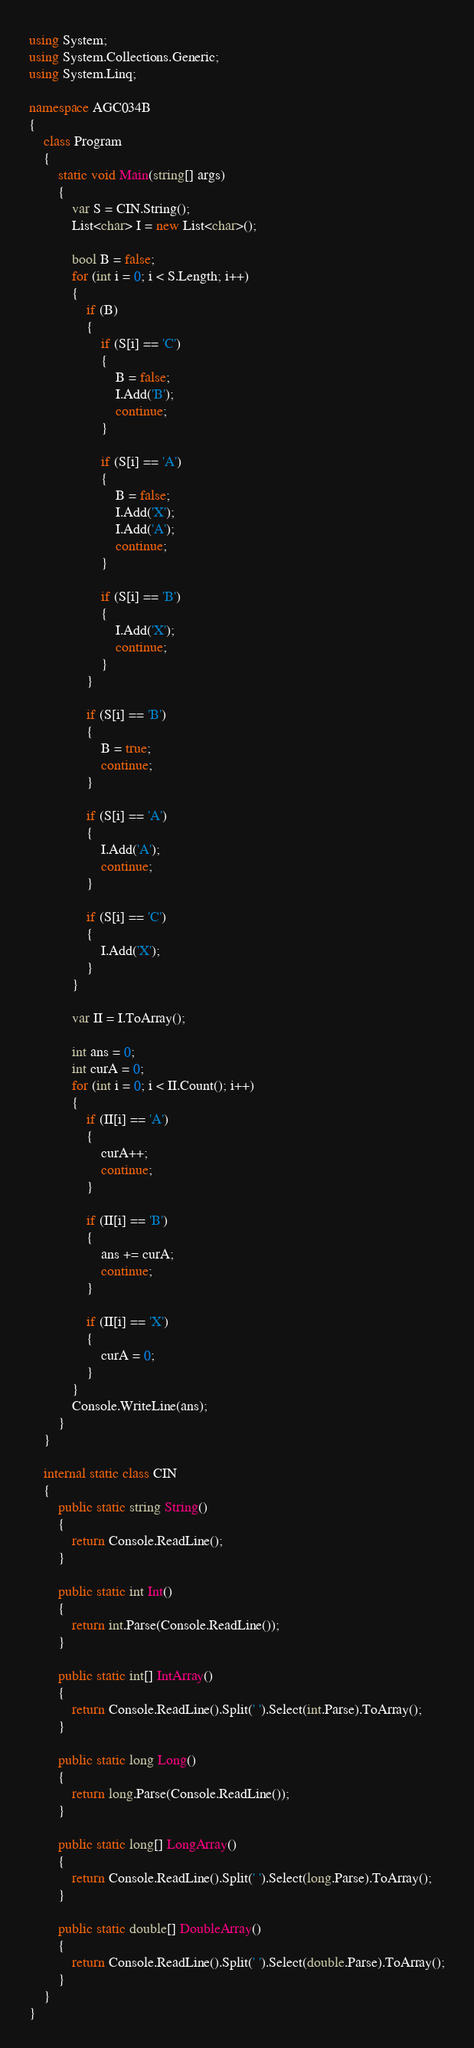<code> <loc_0><loc_0><loc_500><loc_500><_C#_>using System;
using System.Collections.Generic;
using System.Linq;

namespace AGC034B
{
    class Program
    {
        static void Main(string[] args)
        {
            var S = CIN.String();
            List<char> I = new List<char>();

            bool B = false;
            for (int i = 0; i < S.Length; i++)
            {
                if (B)
                {
                    if (S[i] == 'C')
                    {
                        B = false;
                        I.Add('B');
                        continue;
                    }

                    if (S[i] == 'A')
                    {
                        B = false;
                        I.Add('X');
                        I.Add('A');
                        continue;
                    }

                    if (S[i] == 'B')
                    {
                        I.Add('X');
                        continue;
                    }
                }

                if (S[i] == 'B')
                {
                    B = true;
                    continue;
                }

                if (S[i] == 'A')
                {
                    I.Add('A');
                    continue;
                }

                if (S[i] == 'C')
                {
                    I.Add('X');
                }
            }

            var II = I.ToArray();

            int ans = 0;
            int curA = 0;
            for (int i = 0; i < II.Count(); i++)
            {
                if (II[i] == 'A')
                {
                    curA++;
                    continue;
                }

                if (II[i] == 'B')
                {
                    ans += curA;
                    continue;
                }

                if (II[i] == 'X')
                {
                    curA = 0;
                }
            }
            Console.WriteLine(ans);
        }
    }

    internal static class CIN
    {
        public static string String()
        {
            return Console.ReadLine();
        }

        public static int Int()
        {
            return int.Parse(Console.ReadLine());
        }

        public static int[] IntArray()
        {
            return Console.ReadLine().Split(' ').Select(int.Parse).ToArray();
        }

        public static long Long()
        {
            return long.Parse(Console.ReadLine());
        }

        public static long[] LongArray()
        {
            return Console.ReadLine().Split(' ').Select(long.Parse).ToArray();
        }

        public static double[] DoubleArray()
        {
            return Console.ReadLine().Split(' ').Select(double.Parse).ToArray();
        }
    }
}</code> 